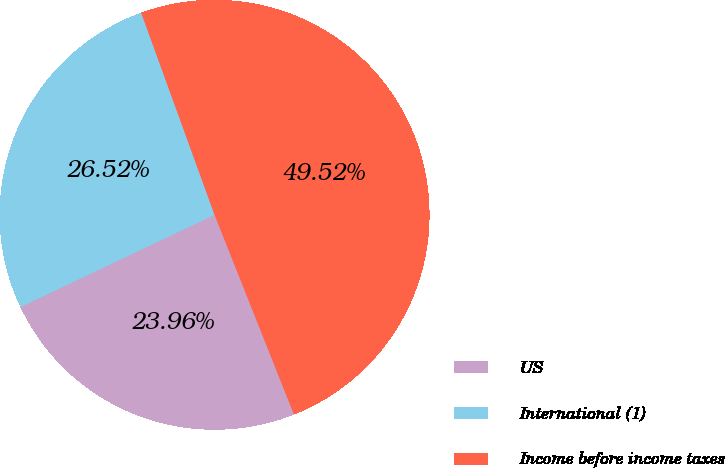<chart> <loc_0><loc_0><loc_500><loc_500><pie_chart><fcel>US<fcel>International (1)<fcel>Income before income taxes<nl><fcel>23.96%<fcel>26.52%<fcel>49.52%<nl></chart> 